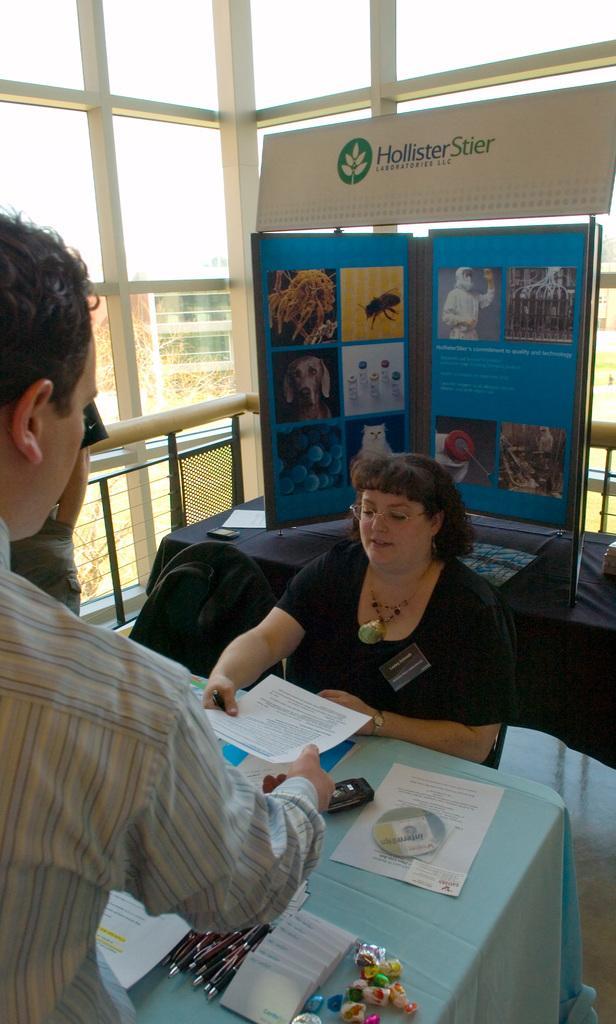Can you describe this image briefly? In this image I can see few people with different color dresses. I can see one person is holding the paper. There is a table in-front of these people. On the table there are pens, papers and some objects. In the background I can see the colorful board. I can also see the building, sky in the back. 